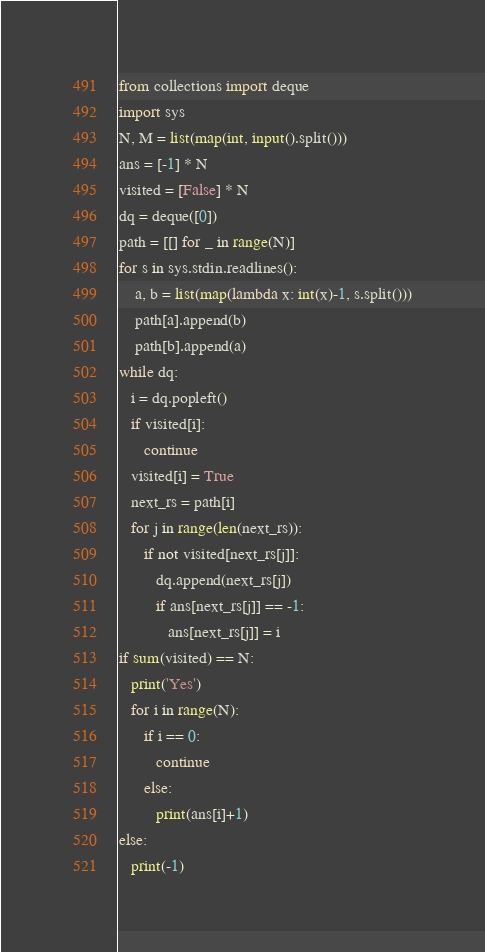Convert code to text. <code><loc_0><loc_0><loc_500><loc_500><_Python_>from collections import deque
import sys
N, M = list(map(int, input().split()))
ans = [-1] * N
visited = [False] * N
dq = deque([0])
path = [[] for _ in range(N)]
for s in sys.stdin.readlines():
    a, b = list(map(lambda x: int(x)-1, s.split()))
    path[a].append(b)
    path[b].append(a)
while dq:
   i = dq.popleft()
   if visited[i]:
      continue
   visited[i] = True
   next_rs = path[i]
   for j in range(len(next_rs)):
      if not visited[next_rs[j]]:
         dq.append(next_rs[j])
         if ans[next_rs[j]] == -1:
            ans[next_rs[j]] = i
if sum(visited) == N:
   print('Yes')
   for i in range(N):
      if i == 0:
         continue
      else:
         print(ans[i]+1)
else:
   print(-1)</code> 